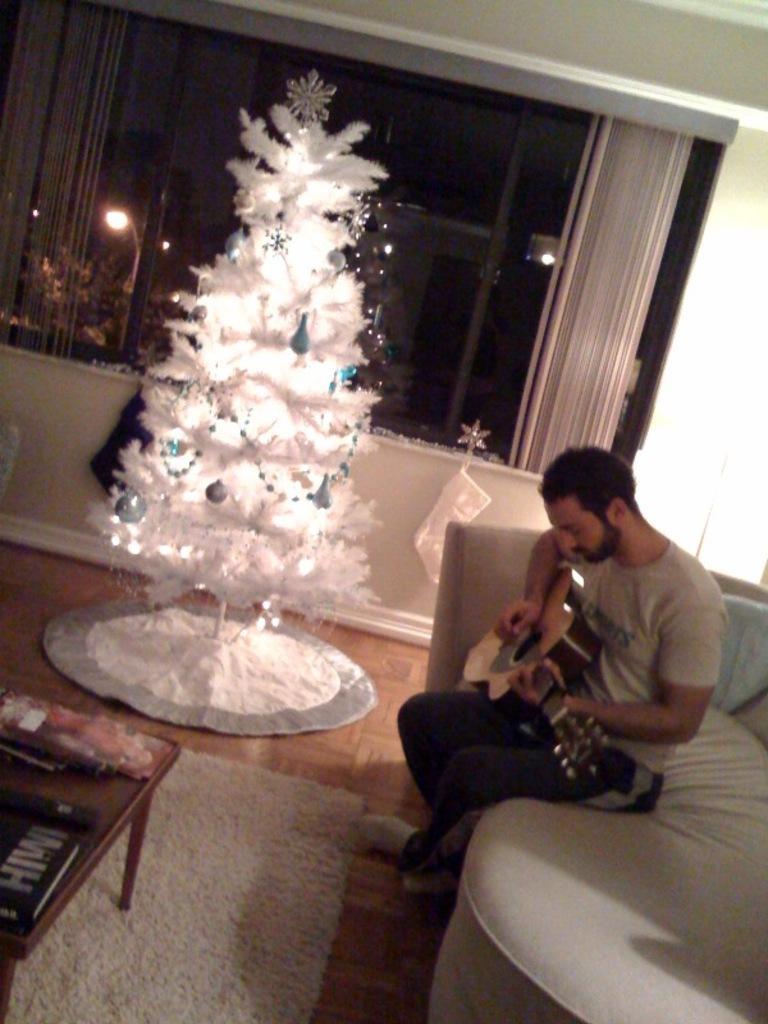Can you describe this image briefly? There is a room. On the right side we have a person. He is sitting on a sofa. He is playing a guitar. In the center we have a Christmas tree. We can see in background window ,curtain and wall. 